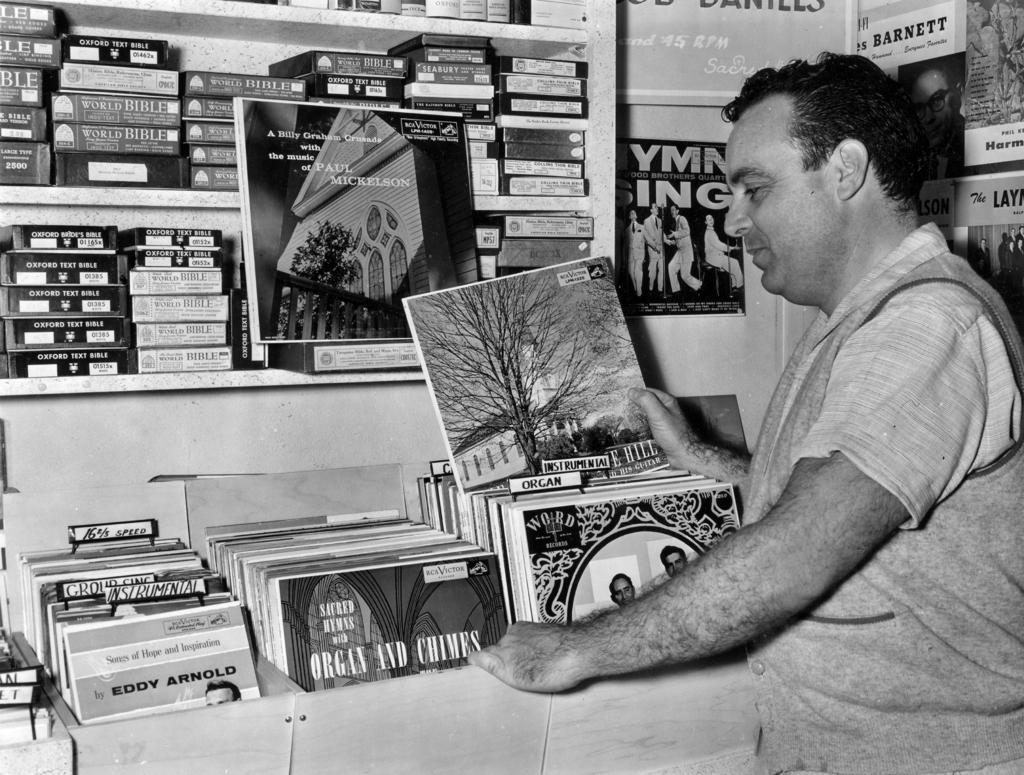Can you describe this image briefly? In this image we can see a man standing and holding a book in his hands. In the background we can see many books arranged in the shelves. 